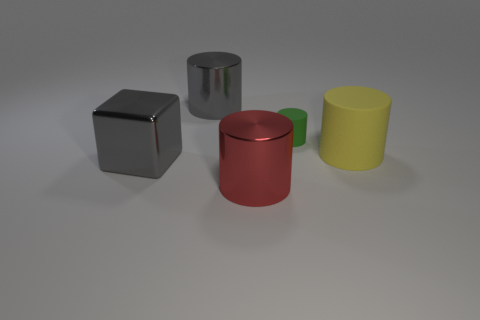Subtract 1 cylinders. How many cylinders are left? 3 Add 5 big yellow rubber cylinders. How many objects exist? 10 Subtract all cylinders. How many objects are left? 1 Add 5 shiny cubes. How many shiny cubes exist? 6 Subtract 0 green balls. How many objects are left? 5 Subtract all red cylinders. Subtract all green things. How many objects are left? 3 Add 2 large yellow matte objects. How many large yellow matte objects are left? 3 